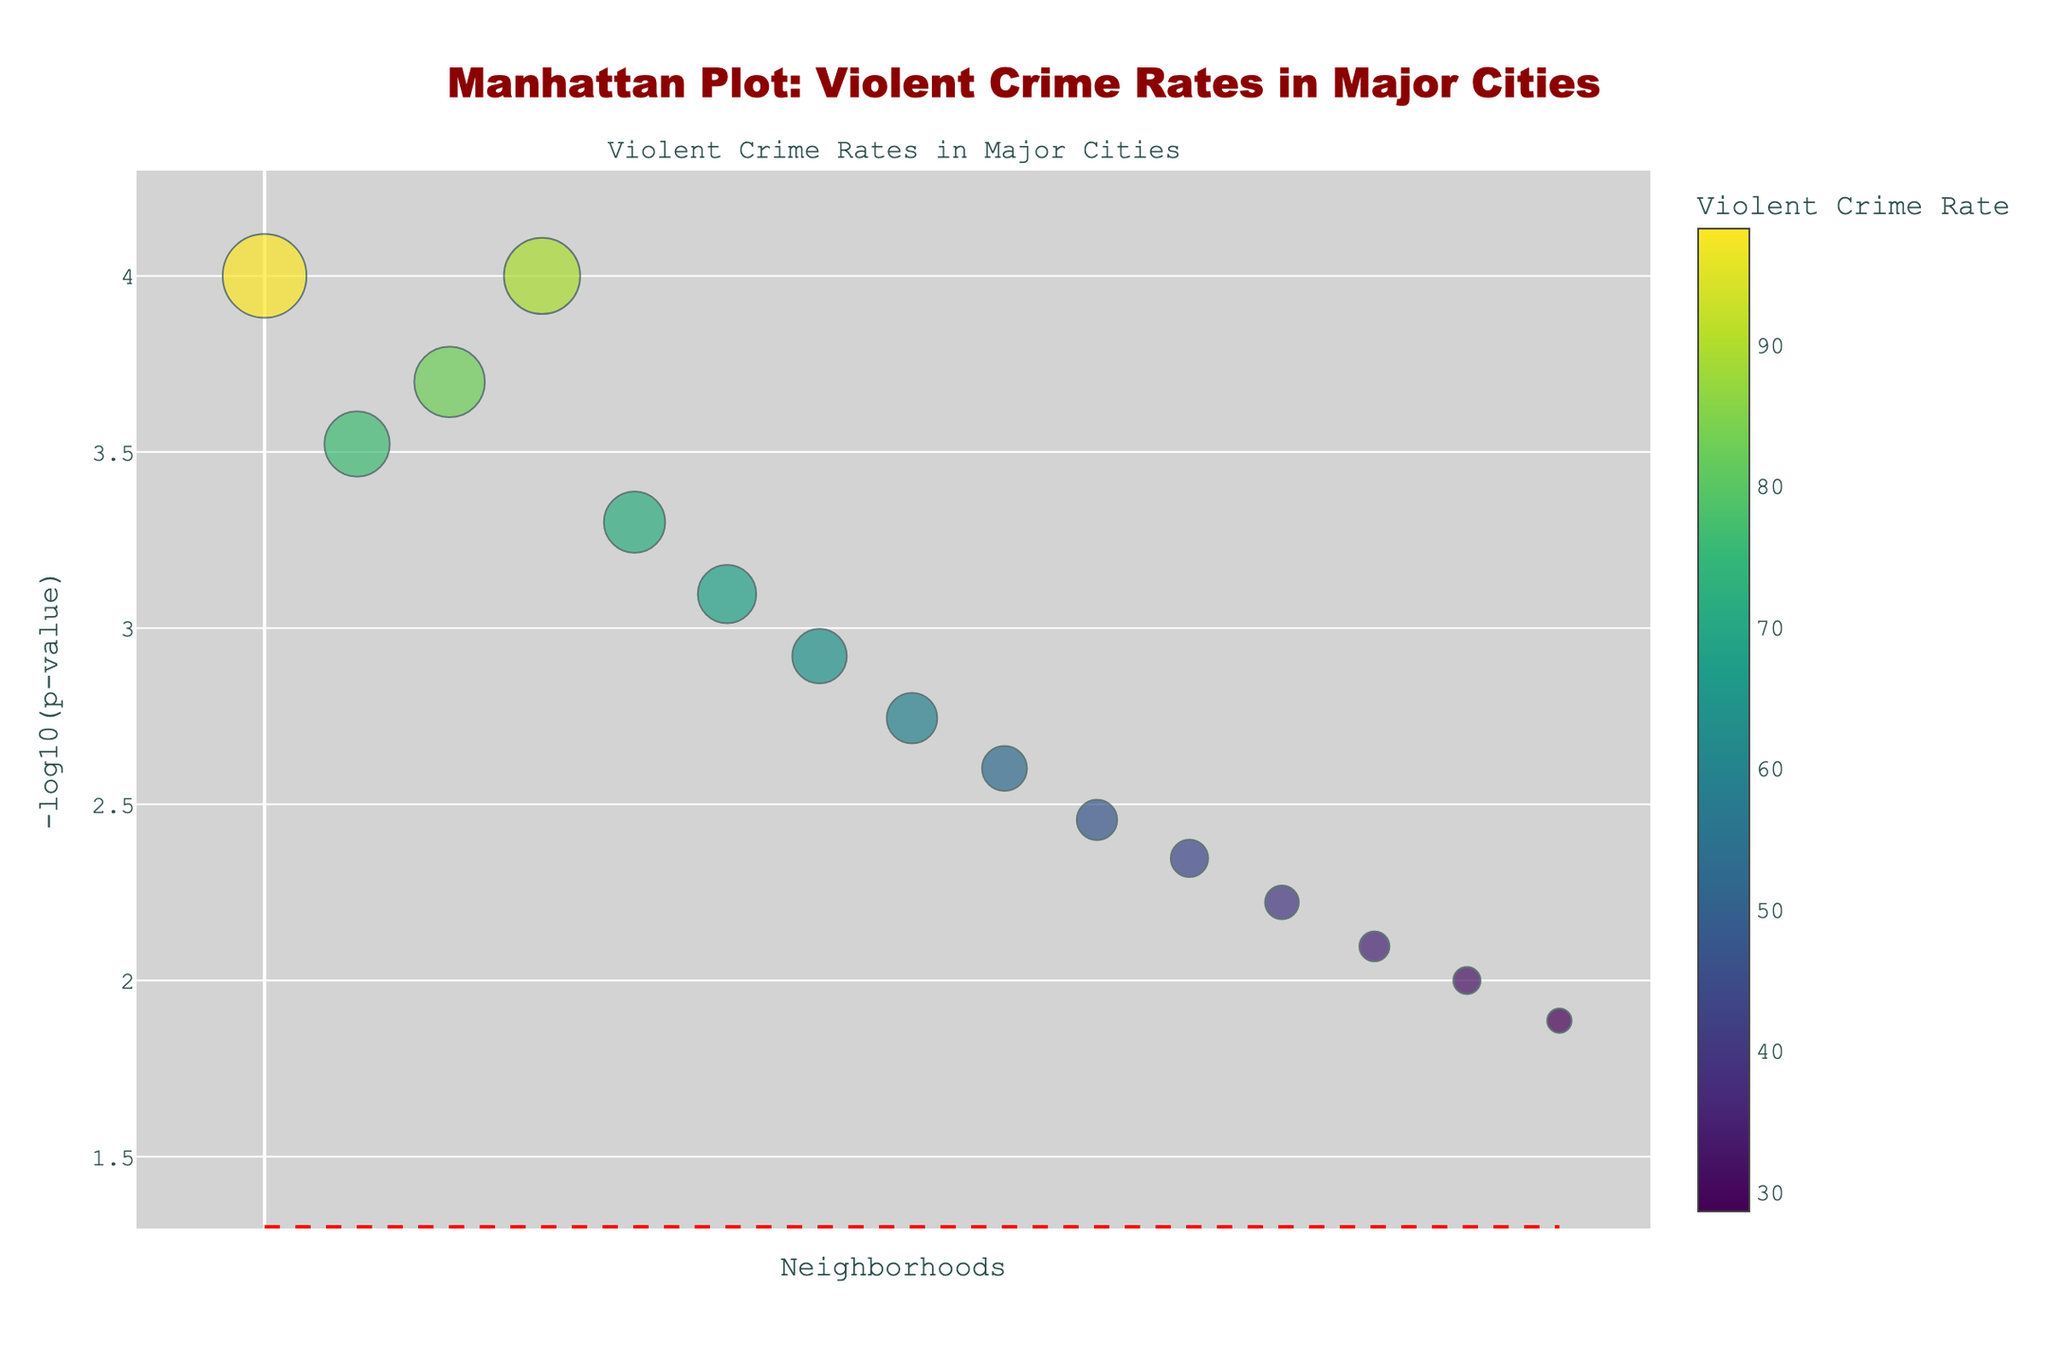What's the title of the plot? The title is usually placed at the top center of the figure in a prominent font. In this plot, it is written in dark red and specifies the content of the figure.
Answer: Manhattan Plot: Violent Crime Rates in Major Cities How many neighborhoods are plotted in the figure? The neighborhoods can be counted by looking at the number of data points or markers on the plot. Each marker represents one neighborhood.
Answer: 15 Which neighborhood has the highest violent crime rate? The violent crime rate is indicated by the size and color of the markers. The largest marker with the highest value on the color scale corresponds to the neighborhood with the highest crime rate.
Answer: Tenderloin What is represented on the x-axis of the plot? The x-axis usually shows the categories or labels relevant to the data points. In this plot, it represents the neighborhoods.
Answer: Neighborhoods What's the value of the statistical significance threshold depicted by a dashed line in the plot? The dashed line on the y-axis is a threshold for statistical significance, which is often set to a p-value of 0.05. The value is transformed by -log10, so -log10(0.05) equals this value.
Answer: 1.3 Which neighborhoods have a statistically significant violent crime rate, considering the threshold line? Statistically significant neighborhoods are those above the threshold line. You need to identify the markers situated higher than approximately 1.3 on the y-axis.
Answer: Tenderloin, South Bronx, Englewood, Skid Row, Central City East Compare the violent crime rates of Englewood (Chicago) and Skid Row (Los Angeles). Which one is higher? By examining the sizes and colors of the markers for Englewood and Skid Row, the one with a larger size and darker color indicates a higher crime rate.
Answer: Skid Row What's the rank of Anacostia (Washington D.C.) based on the statistical significance of its violent crime rate in the figure? To determine the rank, observe the y-axis values and order the markers from highest to lowest. The position of Anacostia represents its rank.
Answer: 8th How does the violent crime rate of Hillbrow (Johannesburg) compare to that of Dharavi (Mumbai)? By checking the sizes and colors of the markers for Hillbrow and Dharavi, the one with a larger size and more intense color has a higher crime rate.
Answer: Hillbrow If a neighborhood's p-value is 0.0001, where would it fall on the plot in terms of -log10(p-value)? Calculate -log10(0.0001). The neighborhood with this p-value will be positioned at this y-axis value in the figure.
Answer: 4 